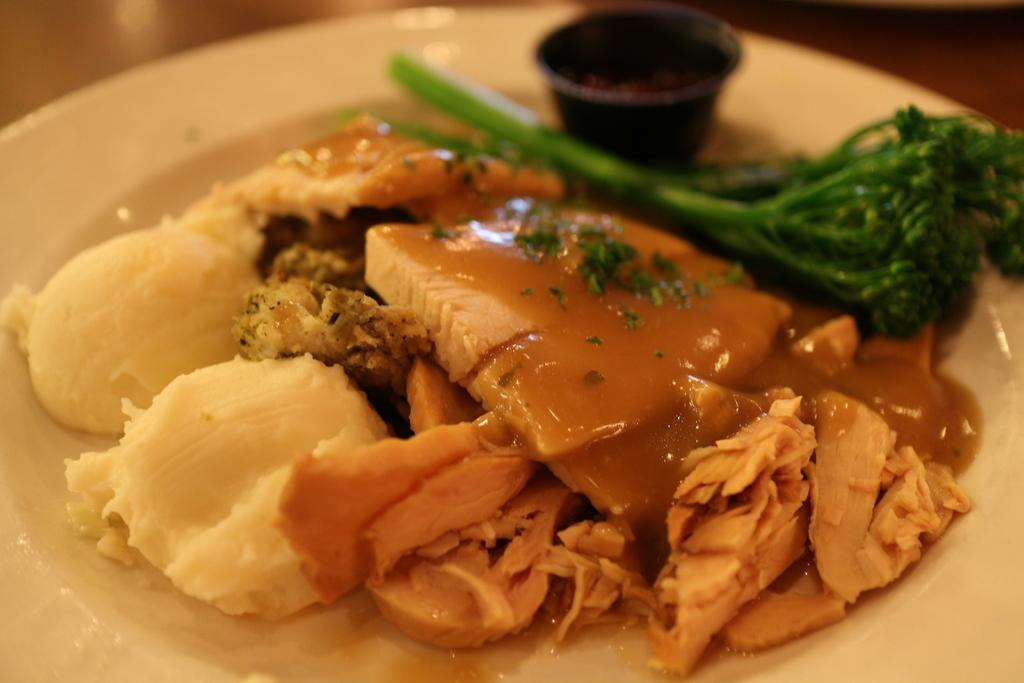What type of items are present in the image? There are eatables in the image. On what are the eatables placed? The eatables are placed on a white plate. What invention can be seen on the page in the image? There is no page or invention present in the image; it only features eatables placed on a white plate. 